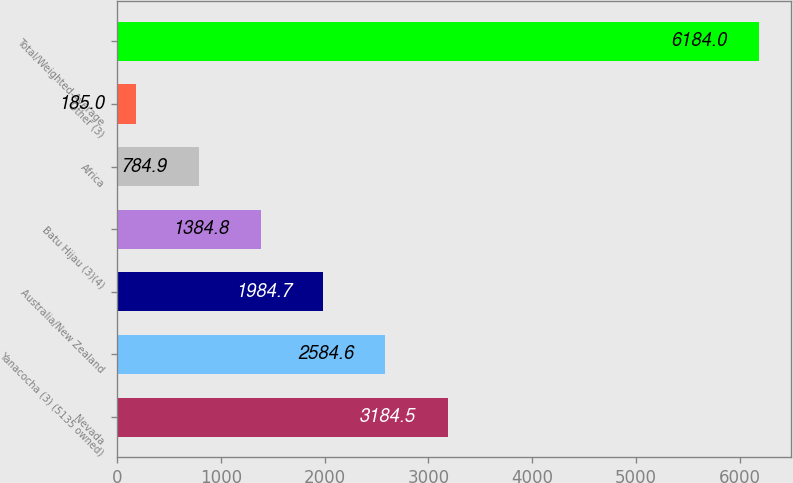Convert chart to OTSL. <chart><loc_0><loc_0><loc_500><loc_500><bar_chart><fcel>Nevada<fcel>Yanacocha (3) (5135 owned)<fcel>Australia/New Zealand<fcel>Batu Hijau (3)(4)<fcel>Africa<fcel>Other (3)<fcel>Total/Weighted-Average<nl><fcel>3184.5<fcel>2584.6<fcel>1984.7<fcel>1384.8<fcel>784.9<fcel>185<fcel>6184<nl></chart> 